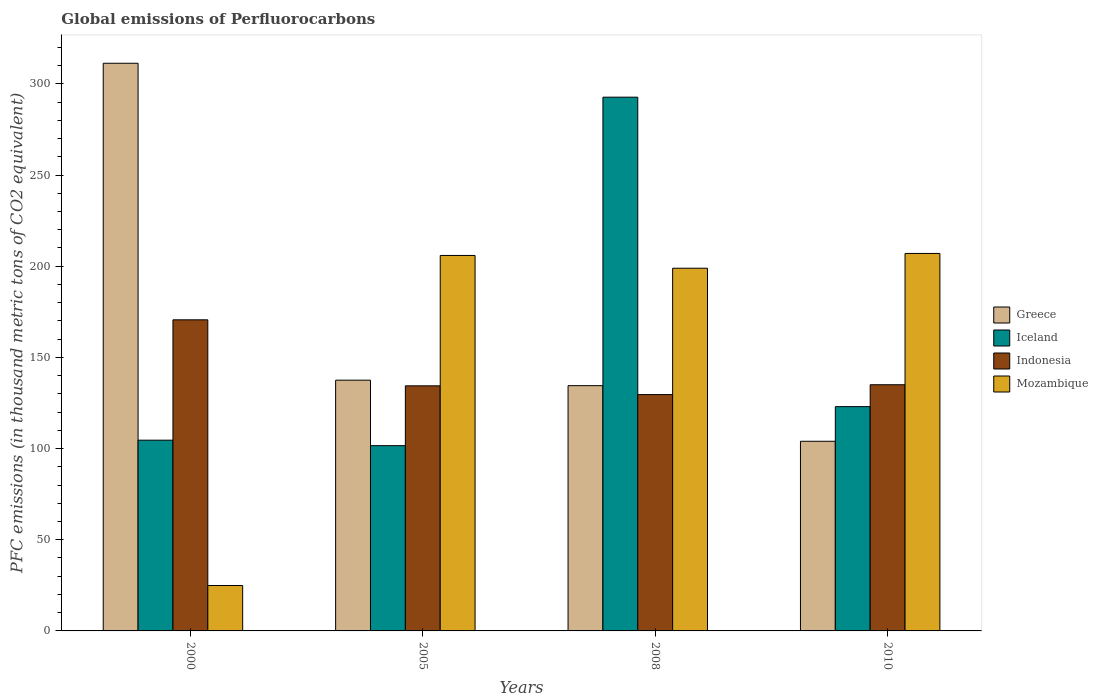How many groups of bars are there?
Provide a short and direct response. 4. Are the number of bars per tick equal to the number of legend labels?
Provide a short and direct response. Yes. Are the number of bars on each tick of the X-axis equal?
Give a very brief answer. Yes. How many bars are there on the 2nd tick from the left?
Give a very brief answer. 4. How many bars are there on the 3rd tick from the right?
Offer a terse response. 4. What is the label of the 2nd group of bars from the left?
Give a very brief answer. 2005. What is the global emissions of Perfluorocarbons in Iceland in 2008?
Keep it short and to the point. 292.7. Across all years, what is the maximum global emissions of Perfluorocarbons in Mozambique?
Make the answer very short. 207. Across all years, what is the minimum global emissions of Perfluorocarbons in Mozambique?
Offer a very short reply. 24.9. In which year was the global emissions of Perfluorocarbons in Greece maximum?
Your answer should be compact. 2000. What is the total global emissions of Perfluorocarbons in Indonesia in the graph?
Make the answer very short. 569.6. What is the difference between the global emissions of Perfluorocarbons in Indonesia in 2008 and that in 2010?
Provide a succinct answer. -5.4. What is the difference between the global emissions of Perfluorocarbons in Indonesia in 2000 and the global emissions of Perfluorocarbons in Greece in 2005?
Your response must be concise. 33.1. What is the average global emissions of Perfluorocarbons in Mozambique per year?
Ensure brevity in your answer.  159.18. In the year 2010, what is the difference between the global emissions of Perfluorocarbons in Greece and global emissions of Perfluorocarbons in Indonesia?
Give a very brief answer. -31. What is the ratio of the global emissions of Perfluorocarbons in Greece in 2005 to that in 2010?
Your response must be concise. 1.32. Is the difference between the global emissions of Perfluorocarbons in Greece in 2008 and 2010 greater than the difference between the global emissions of Perfluorocarbons in Indonesia in 2008 and 2010?
Your answer should be compact. Yes. What is the difference between the highest and the second highest global emissions of Perfluorocarbons in Mozambique?
Make the answer very short. 1.1. What is the difference between the highest and the lowest global emissions of Perfluorocarbons in Iceland?
Provide a succinct answer. 191.1. In how many years, is the global emissions of Perfluorocarbons in Greece greater than the average global emissions of Perfluorocarbons in Greece taken over all years?
Give a very brief answer. 1. Is it the case that in every year, the sum of the global emissions of Perfluorocarbons in Iceland and global emissions of Perfluorocarbons in Mozambique is greater than the sum of global emissions of Perfluorocarbons in Indonesia and global emissions of Perfluorocarbons in Greece?
Give a very brief answer. No. Is it the case that in every year, the sum of the global emissions of Perfluorocarbons in Indonesia and global emissions of Perfluorocarbons in Iceland is greater than the global emissions of Perfluorocarbons in Mozambique?
Provide a succinct answer. Yes. How many bars are there?
Your response must be concise. 16. Are all the bars in the graph horizontal?
Provide a short and direct response. No. How many years are there in the graph?
Your response must be concise. 4. Where does the legend appear in the graph?
Provide a succinct answer. Center right. How many legend labels are there?
Provide a succinct answer. 4. What is the title of the graph?
Provide a succinct answer. Global emissions of Perfluorocarbons. What is the label or title of the Y-axis?
Provide a succinct answer. PFC emissions (in thousand metric tons of CO2 equivalent). What is the PFC emissions (in thousand metric tons of CO2 equivalent) of Greece in 2000?
Provide a short and direct response. 311.3. What is the PFC emissions (in thousand metric tons of CO2 equivalent) of Iceland in 2000?
Provide a short and direct response. 104.6. What is the PFC emissions (in thousand metric tons of CO2 equivalent) in Indonesia in 2000?
Keep it short and to the point. 170.6. What is the PFC emissions (in thousand metric tons of CO2 equivalent) of Mozambique in 2000?
Offer a terse response. 24.9. What is the PFC emissions (in thousand metric tons of CO2 equivalent) of Greece in 2005?
Ensure brevity in your answer.  137.5. What is the PFC emissions (in thousand metric tons of CO2 equivalent) in Iceland in 2005?
Your answer should be compact. 101.6. What is the PFC emissions (in thousand metric tons of CO2 equivalent) of Indonesia in 2005?
Make the answer very short. 134.4. What is the PFC emissions (in thousand metric tons of CO2 equivalent) of Mozambique in 2005?
Your answer should be compact. 205.9. What is the PFC emissions (in thousand metric tons of CO2 equivalent) of Greece in 2008?
Provide a short and direct response. 134.5. What is the PFC emissions (in thousand metric tons of CO2 equivalent) in Iceland in 2008?
Make the answer very short. 292.7. What is the PFC emissions (in thousand metric tons of CO2 equivalent) in Indonesia in 2008?
Your answer should be very brief. 129.6. What is the PFC emissions (in thousand metric tons of CO2 equivalent) of Mozambique in 2008?
Offer a very short reply. 198.9. What is the PFC emissions (in thousand metric tons of CO2 equivalent) in Greece in 2010?
Give a very brief answer. 104. What is the PFC emissions (in thousand metric tons of CO2 equivalent) in Iceland in 2010?
Keep it short and to the point. 123. What is the PFC emissions (in thousand metric tons of CO2 equivalent) in Indonesia in 2010?
Provide a short and direct response. 135. What is the PFC emissions (in thousand metric tons of CO2 equivalent) in Mozambique in 2010?
Your answer should be very brief. 207. Across all years, what is the maximum PFC emissions (in thousand metric tons of CO2 equivalent) in Greece?
Your response must be concise. 311.3. Across all years, what is the maximum PFC emissions (in thousand metric tons of CO2 equivalent) in Iceland?
Provide a short and direct response. 292.7. Across all years, what is the maximum PFC emissions (in thousand metric tons of CO2 equivalent) in Indonesia?
Your answer should be compact. 170.6. Across all years, what is the maximum PFC emissions (in thousand metric tons of CO2 equivalent) in Mozambique?
Make the answer very short. 207. Across all years, what is the minimum PFC emissions (in thousand metric tons of CO2 equivalent) of Greece?
Ensure brevity in your answer.  104. Across all years, what is the minimum PFC emissions (in thousand metric tons of CO2 equivalent) in Iceland?
Provide a short and direct response. 101.6. Across all years, what is the minimum PFC emissions (in thousand metric tons of CO2 equivalent) in Indonesia?
Make the answer very short. 129.6. Across all years, what is the minimum PFC emissions (in thousand metric tons of CO2 equivalent) in Mozambique?
Make the answer very short. 24.9. What is the total PFC emissions (in thousand metric tons of CO2 equivalent) in Greece in the graph?
Your response must be concise. 687.3. What is the total PFC emissions (in thousand metric tons of CO2 equivalent) of Iceland in the graph?
Provide a succinct answer. 621.9. What is the total PFC emissions (in thousand metric tons of CO2 equivalent) of Indonesia in the graph?
Offer a terse response. 569.6. What is the total PFC emissions (in thousand metric tons of CO2 equivalent) of Mozambique in the graph?
Your answer should be compact. 636.7. What is the difference between the PFC emissions (in thousand metric tons of CO2 equivalent) of Greece in 2000 and that in 2005?
Give a very brief answer. 173.8. What is the difference between the PFC emissions (in thousand metric tons of CO2 equivalent) of Indonesia in 2000 and that in 2005?
Offer a very short reply. 36.2. What is the difference between the PFC emissions (in thousand metric tons of CO2 equivalent) in Mozambique in 2000 and that in 2005?
Provide a short and direct response. -181. What is the difference between the PFC emissions (in thousand metric tons of CO2 equivalent) of Greece in 2000 and that in 2008?
Give a very brief answer. 176.8. What is the difference between the PFC emissions (in thousand metric tons of CO2 equivalent) in Iceland in 2000 and that in 2008?
Ensure brevity in your answer.  -188.1. What is the difference between the PFC emissions (in thousand metric tons of CO2 equivalent) of Indonesia in 2000 and that in 2008?
Your answer should be very brief. 41. What is the difference between the PFC emissions (in thousand metric tons of CO2 equivalent) of Mozambique in 2000 and that in 2008?
Your response must be concise. -174. What is the difference between the PFC emissions (in thousand metric tons of CO2 equivalent) in Greece in 2000 and that in 2010?
Provide a succinct answer. 207.3. What is the difference between the PFC emissions (in thousand metric tons of CO2 equivalent) of Iceland in 2000 and that in 2010?
Ensure brevity in your answer.  -18.4. What is the difference between the PFC emissions (in thousand metric tons of CO2 equivalent) in Indonesia in 2000 and that in 2010?
Keep it short and to the point. 35.6. What is the difference between the PFC emissions (in thousand metric tons of CO2 equivalent) of Mozambique in 2000 and that in 2010?
Your answer should be compact. -182.1. What is the difference between the PFC emissions (in thousand metric tons of CO2 equivalent) in Iceland in 2005 and that in 2008?
Offer a terse response. -191.1. What is the difference between the PFC emissions (in thousand metric tons of CO2 equivalent) in Mozambique in 2005 and that in 2008?
Ensure brevity in your answer.  7. What is the difference between the PFC emissions (in thousand metric tons of CO2 equivalent) in Greece in 2005 and that in 2010?
Make the answer very short. 33.5. What is the difference between the PFC emissions (in thousand metric tons of CO2 equivalent) of Iceland in 2005 and that in 2010?
Make the answer very short. -21.4. What is the difference between the PFC emissions (in thousand metric tons of CO2 equivalent) in Indonesia in 2005 and that in 2010?
Your answer should be compact. -0.6. What is the difference between the PFC emissions (in thousand metric tons of CO2 equivalent) in Mozambique in 2005 and that in 2010?
Your response must be concise. -1.1. What is the difference between the PFC emissions (in thousand metric tons of CO2 equivalent) of Greece in 2008 and that in 2010?
Offer a terse response. 30.5. What is the difference between the PFC emissions (in thousand metric tons of CO2 equivalent) in Iceland in 2008 and that in 2010?
Make the answer very short. 169.7. What is the difference between the PFC emissions (in thousand metric tons of CO2 equivalent) of Indonesia in 2008 and that in 2010?
Give a very brief answer. -5.4. What is the difference between the PFC emissions (in thousand metric tons of CO2 equivalent) in Mozambique in 2008 and that in 2010?
Give a very brief answer. -8.1. What is the difference between the PFC emissions (in thousand metric tons of CO2 equivalent) in Greece in 2000 and the PFC emissions (in thousand metric tons of CO2 equivalent) in Iceland in 2005?
Keep it short and to the point. 209.7. What is the difference between the PFC emissions (in thousand metric tons of CO2 equivalent) in Greece in 2000 and the PFC emissions (in thousand metric tons of CO2 equivalent) in Indonesia in 2005?
Ensure brevity in your answer.  176.9. What is the difference between the PFC emissions (in thousand metric tons of CO2 equivalent) in Greece in 2000 and the PFC emissions (in thousand metric tons of CO2 equivalent) in Mozambique in 2005?
Make the answer very short. 105.4. What is the difference between the PFC emissions (in thousand metric tons of CO2 equivalent) of Iceland in 2000 and the PFC emissions (in thousand metric tons of CO2 equivalent) of Indonesia in 2005?
Provide a short and direct response. -29.8. What is the difference between the PFC emissions (in thousand metric tons of CO2 equivalent) in Iceland in 2000 and the PFC emissions (in thousand metric tons of CO2 equivalent) in Mozambique in 2005?
Your answer should be compact. -101.3. What is the difference between the PFC emissions (in thousand metric tons of CO2 equivalent) of Indonesia in 2000 and the PFC emissions (in thousand metric tons of CO2 equivalent) of Mozambique in 2005?
Ensure brevity in your answer.  -35.3. What is the difference between the PFC emissions (in thousand metric tons of CO2 equivalent) of Greece in 2000 and the PFC emissions (in thousand metric tons of CO2 equivalent) of Iceland in 2008?
Make the answer very short. 18.6. What is the difference between the PFC emissions (in thousand metric tons of CO2 equivalent) in Greece in 2000 and the PFC emissions (in thousand metric tons of CO2 equivalent) in Indonesia in 2008?
Offer a very short reply. 181.7. What is the difference between the PFC emissions (in thousand metric tons of CO2 equivalent) in Greece in 2000 and the PFC emissions (in thousand metric tons of CO2 equivalent) in Mozambique in 2008?
Your answer should be compact. 112.4. What is the difference between the PFC emissions (in thousand metric tons of CO2 equivalent) in Iceland in 2000 and the PFC emissions (in thousand metric tons of CO2 equivalent) in Indonesia in 2008?
Offer a terse response. -25. What is the difference between the PFC emissions (in thousand metric tons of CO2 equivalent) of Iceland in 2000 and the PFC emissions (in thousand metric tons of CO2 equivalent) of Mozambique in 2008?
Keep it short and to the point. -94.3. What is the difference between the PFC emissions (in thousand metric tons of CO2 equivalent) of Indonesia in 2000 and the PFC emissions (in thousand metric tons of CO2 equivalent) of Mozambique in 2008?
Make the answer very short. -28.3. What is the difference between the PFC emissions (in thousand metric tons of CO2 equivalent) of Greece in 2000 and the PFC emissions (in thousand metric tons of CO2 equivalent) of Iceland in 2010?
Give a very brief answer. 188.3. What is the difference between the PFC emissions (in thousand metric tons of CO2 equivalent) in Greece in 2000 and the PFC emissions (in thousand metric tons of CO2 equivalent) in Indonesia in 2010?
Your response must be concise. 176.3. What is the difference between the PFC emissions (in thousand metric tons of CO2 equivalent) in Greece in 2000 and the PFC emissions (in thousand metric tons of CO2 equivalent) in Mozambique in 2010?
Offer a very short reply. 104.3. What is the difference between the PFC emissions (in thousand metric tons of CO2 equivalent) in Iceland in 2000 and the PFC emissions (in thousand metric tons of CO2 equivalent) in Indonesia in 2010?
Keep it short and to the point. -30.4. What is the difference between the PFC emissions (in thousand metric tons of CO2 equivalent) in Iceland in 2000 and the PFC emissions (in thousand metric tons of CO2 equivalent) in Mozambique in 2010?
Ensure brevity in your answer.  -102.4. What is the difference between the PFC emissions (in thousand metric tons of CO2 equivalent) of Indonesia in 2000 and the PFC emissions (in thousand metric tons of CO2 equivalent) of Mozambique in 2010?
Keep it short and to the point. -36.4. What is the difference between the PFC emissions (in thousand metric tons of CO2 equivalent) in Greece in 2005 and the PFC emissions (in thousand metric tons of CO2 equivalent) in Iceland in 2008?
Offer a terse response. -155.2. What is the difference between the PFC emissions (in thousand metric tons of CO2 equivalent) of Greece in 2005 and the PFC emissions (in thousand metric tons of CO2 equivalent) of Indonesia in 2008?
Make the answer very short. 7.9. What is the difference between the PFC emissions (in thousand metric tons of CO2 equivalent) in Greece in 2005 and the PFC emissions (in thousand metric tons of CO2 equivalent) in Mozambique in 2008?
Provide a succinct answer. -61.4. What is the difference between the PFC emissions (in thousand metric tons of CO2 equivalent) in Iceland in 2005 and the PFC emissions (in thousand metric tons of CO2 equivalent) in Indonesia in 2008?
Keep it short and to the point. -28. What is the difference between the PFC emissions (in thousand metric tons of CO2 equivalent) in Iceland in 2005 and the PFC emissions (in thousand metric tons of CO2 equivalent) in Mozambique in 2008?
Your answer should be compact. -97.3. What is the difference between the PFC emissions (in thousand metric tons of CO2 equivalent) of Indonesia in 2005 and the PFC emissions (in thousand metric tons of CO2 equivalent) of Mozambique in 2008?
Offer a terse response. -64.5. What is the difference between the PFC emissions (in thousand metric tons of CO2 equivalent) of Greece in 2005 and the PFC emissions (in thousand metric tons of CO2 equivalent) of Mozambique in 2010?
Keep it short and to the point. -69.5. What is the difference between the PFC emissions (in thousand metric tons of CO2 equivalent) of Iceland in 2005 and the PFC emissions (in thousand metric tons of CO2 equivalent) of Indonesia in 2010?
Your answer should be compact. -33.4. What is the difference between the PFC emissions (in thousand metric tons of CO2 equivalent) of Iceland in 2005 and the PFC emissions (in thousand metric tons of CO2 equivalent) of Mozambique in 2010?
Make the answer very short. -105.4. What is the difference between the PFC emissions (in thousand metric tons of CO2 equivalent) in Indonesia in 2005 and the PFC emissions (in thousand metric tons of CO2 equivalent) in Mozambique in 2010?
Provide a succinct answer. -72.6. What is the difference between the PFC emissions (in thousand metric tons of CO2 equivalent) of Greece in 2008 and the PFC emissions (in thousand metric tons of CO2 equivalent) of Iceland in 2010?
Make the answer very short. 11.5. What is the difference between the PFC emissions (in thousand metric tons of CO2 equivalent) of Greece in 2008 and the PFC emissions (in thousand metric tons of CO2 equivalent) of Mozambique in 2010?
Your response must be concise. -72.5. What is the difference between the PFC emissions (in thousand metric tons of CO2 equivalent) of Iceland in 2008 and the PFC emissions (in thousand metric tons of CO2 equivalent) of Indonesia in 2010?
Provide a short and direct response. 157.7. What is the difference between the PFC emissions (in thousand metric tons of CO2 equivalent) in Iceland in 2008 and the PFC emissions (in thousand metric tons of CO2 equivalent) in Mozambique in 2010?
Your response must be concise. 85.7. What is the difference between the PFC emissions (in thousand metric tons of CO2 equivalent) in Indonesia in 2008 and the PFC emissions (in thousand metric tons of CO2 equivalent) in Mozambique in 2010?
Make the answer very short. -77.4. What is the average PFC emissions (in thousand metric tons of CO2 equivalent) of Greece per year?
Provide a succinct answer. 171.82. What is the average PFC emissions (in thousand metric tons of CO2 equivalent) in Iceland per year?
Your answer should be compact. 155.47. What is the average PFC emissions (in thousand metric tons of CO2 equivalent) in Indonesia per year?
Provide a short and direct response. 142.4. What is the average PFC emissions (in thousand metric tons of CO2 equivalent) in Mozambique per year?
Keep it short and to the point. 159.18. In the year 2000, what is the difference between the PFC emissions (in thousand metric tons of CO2 equivalent) in Greece and PFC emissions (in thousand metric tons of CO2 equivalent) in Iceland?
Ensure brevity in your answer.  206.7. In the year 2000, what is the difference between the PFC emissions (in thousand metric tons of CO2 equivalent) in Greece and PFC emissions (in thousand metric tons of CO2 equivalent) in Indonesia?
Offer a very short reply. 140.7. In the year 2000, what is the difference between the PFC emissions (in thousand metric tons of CO2 equivalent) in Greece and PFC emissions (in thousand metric tons of CO2 equivalent) in Mozambique?
Your response must be concise. 286.4. In the year 2000, what is the difference between the PFC emissions (in thousand metric tons of CO2 equivalent) in Iceland and PFC emissions (in thousand metric tons of CO2 equivalent) in Indonesia?
Your response must be concise. -66. In the year 2000, what is the difference between the PFC emissions (in thousand metric tons of CO2 equivalent) of Iceland and PFC emissions (in thousand metric tons of CO2 equivalent) of Mozambique?
Keep it short and to the point. 79.7. In the year 2000, what is the difference between the PFC emissions (in thousand metric tons of CO2 equivalent) in Indonesia and PFC emissions (in thousand metric tons of CO2 equivalent) in Mozambique?
Keep it short and to the point. 145.7. In the year 2005, what is the difference between the PFC emissions (in thousand metric tons of CO2 equivalent) of Greece and PFC emissions (in thousand metric tons of CO2 equivalent) of Iceland?
Keep it short and to the point. 35.9. In the year 2005, what is the difference between the PFC emissions (in thousand metric tons of CO2 equivalent) in Greece and PFC emissions (in thousand metric tons of CO2 equivalent) in Mozambique?
Give a very brief answer. -68.4. In the year 2005, what is the difference between the PFC emissions (in thousand metric tons of CO2 equivalent) of Iceland and PFC emissions (in thousand metric tons of CO2 equivalent) of Indonesia?
Ensure brevity in your answer.  -32.8. In the year 2005, what is the difference between the PFC emissions (in thousand metric tons of CO2 equivalent) of Iceland and PFC emissions (in thousand metric tons of CO2 equivalent) of Mozambique?
Offer a very short reply. -104.3. In the year 2005, what is the difference between the PFC emissions (in thousand metric tons of CO2 equivalent) of Indonesia and PFC emissions (in thousand metric tons of CO2 equivalent) of Mozambique?
Make the answer very short. -71.5. In the year 2008, what is the difference between the PFC emissions (in thousand metric tons of CO2 equivalent) in Greece and PFC emissions (in thousand metric tons of CO2 equivalent) in Iceland?
Offer a terse response. -158.2. In the year 2008, what is the difference between the PFC emissions (in thousand metric tons of CO2 equivalent) in Greece and PFC emissions (in thousand metric tons of CO2 equivalent) in Mozambique?
Your answer should be compact. -64.4. In the year 2008, what is the difference between the PFC emissions (in thousand metric tons of CO2 equivalent) in Iceland and PFC emissions (in thousand metric tons of CO2 equivalent) in Indonesia?
Give a very brief answer. 163.1. In the year 2008, what is the difference between the PFC emissions (in thousand metric tons of CO2 equivalent) in Iceland and PFC emissions (in thousand metric tons of CO2 equivalent) in Mozambique?
Give a very brief answer. 93.8. In the year 2008, what is the difference between the PFC emissions (in thousand metric tons of CO2 equivalent) of Indonesia and PFC emissions (in thousand metric tons of CO2 equivalent) of Mozambique?
Your answer should be compact. -69.3. In the year 2010, what is the difference between the PFC emissions (in thousand metric tons of CO2 equivalent) in Greece and PFC emissions (in thousand metric tons of CO2 equivalent) in Indonesia?
Make the answer very short. -31. In the year 2010, what is the difference between the PFC emissions (in thousand metric tons of CO2 equivalent) in Greece and PFC emissions (in thousand metric tons of CO2 equivalent) in Mozambique?
Offer a terse response. -103. In the year 2010, what is the difference between the PFC emissions (in thousand metric tons of CO2 equivalent) of Iceland and PFC emissions (in thousand metric tons of CO2 equivalent) of Mozambique?
Provide a succinct answer. -84. In the year 2010, what is the difference between the PFC emissions (in thousand metric tons of CO2 equivalent) of Indonesia and PFC emissions (in thousand metric tons of CO2 equivalent) of Mozambique?
Provide a succinct answer. -72. What is the ratio of the PFC emissions (in thousand metric tons of CO2 equivalent) of Greece in 2000 to that in 2005?
Provide a succinct answer. 2.26. What is the ratio of the PFC emissions (in thousand metric tons of CO2 equivalent) of Iceland in 2000 to that in 2005?
Provide a short and direct response. 1.03. What is the ratio of the PFC emissions (in thousand metric tons of CO2 equivalent) in Indonesia in 2000 to that in 2005?
Ensure brevity in your answer.  1.27. What is the ratio of the PFC emissions (in thousand metric tons of CO2 equivalent) of Mozambique in 2000 to that in 2005?
Provide a short and direct response. 0.12. What is the ratio of the PFC emissions (in thousand metric tons of CO2 equivalent) of Greece in 2000 to that in 2008?
Make the answer very short. 2.31. What is the ratio of the PFC emissions (in thousand metric tons of CO2 equivalent) of Iceland in 2000 to that in 2008?
Give a very brief answer. 0.36. What is the ratio of the PFC emissions (in thousand metric tons of CO2 equivalent) of Indonesia in 2000 to that in 2008?
Make the answer very short. 1.32. What is the ratio of the PFC emissions (in thousand metric tons of CO2 equivalent) in Mozambique in 2000 to that in 2008?
Keep it short and to the point. 0.13. What is the ratio of the PFC emissions (in thousand metric tons of CO2 equivalent) in Greece in 2000 to that in 2010?
Your answer should be compact. 2.99. What is the ratio of the PFC emissions (in thousand metric tons of CO2 equivalent) in Iceland in 2000 to that in 2010?
Provide a succinct answer. 0.85. What is the ratio of the PFC emissions (in thousand metric tons of CO2 equivalent) of Indonesia in 2000 to that in 2010?
Ensure brevity in your answer.  1.26. What is the ratio of the PFC emissions (in thousand metric tons of CO2 equivalent) in Mozambique in 2000 to that in 2010?
Provide a short and direct response. 0.12. What is the ratio of the PFC emissions (in thousand metric tons of CO2 equivalent) in Greece in 2005 to that in 2008?
Provide a succinct answer. 1.02. What is the ratio of the PFC emissions (in thousand metric tons of CO2 equivalent) in Iceland in 2005 to that in 2008?
Ensure brevity in your answer.  0.35. What is the ratio of the PFC emissions (in thousand metric tons of CO2 equivalent) of Indonesia in 2005 to that in 2008?
Ensure brevity in your answer.  1.04. What is the ratio of the PFC emissions (in thousand metric tons of CO2 equivalent) of Mozambique in 2005 to that in 2008?
Ensure brevity in your answer.  1.04. What is the ratio of the PFC emissions (in thousand metric tons of CO2 equivalent) in Greece in 2005 to that in 2010?
Your answer should be very brief. 1.32. What is the ratio of the PFC emissions (in thousand metric tons of CO2 equivalent) in Iceland in 2005 to that in 2010?
Keep it short and to the point. 0.83. What is the ratio of the PFC emissions (in thousand metric tons of CO2 equivalent) in Indonesia in 2005 to that in 2010?
Offer a very short reply. 1. What is the ratio of the PFC emissions (in thousand metric tons of CO2 equivalent) in Greece in 2008 to that in 2010?
Keep it short and to the point. 1.29. What is the ratio of the PFC emissions (in thousand metric tons of CO2 equivalent) of Iceland in 2008 to that in 2010?
Your response must be concise. 2.38. What is the ratio of the PFC emissions (in thousand metric tons of CO2 equivalent) of Indonesia in 2008 to that in 2010?
Make the answer very short. 0.96. What is the ratio of the PFC emissions (in thousand metric tons of CO2 equivalent) in Mozambique in 2008 to that in 2010?
Your answer should be compact. 0.96. What is the difference between the highest and the second highest PFC emissions (in thousand metric tons of CO2 equivalent) in Greece?
Your response must be concise. 173.8. What is the difference between the highest and the second highest PFC emissions (in thousand metric tons of CO2 equivalent) of Iceland?
Your answer should be very brief. 169.7. What is the difference between the highest and the second highest PFC emissions (in thousand metric tons of CO2 equivalent) in Indonesia?
Offer a terse response. 35.6. What is the difference between the highest and the lowest PFC emissions (in thousand metric tons of CO2 equivalent) in Greece?
Provide a short and direct response. 207.3. What is the difference between the highest and the lowest PFC emissions (in thousand metric tons of CO2 equivalent) of Iceland?
Your response must be concise. 191.1. What is the difference between the highest and the lowest PFC emissions (in thousand metric tons of CO2 equivalent) in Mozambique?
Provide a short and direct response. 182.1. 